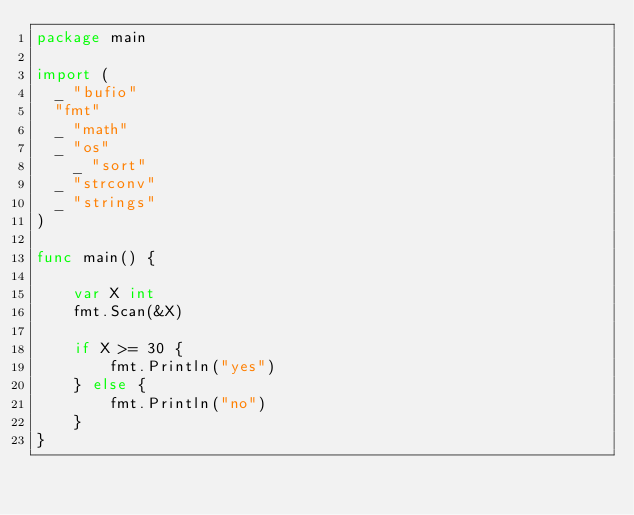Convert code to text. <code><loc_0><loc_0><loc_500><loc_500><_Go_>package main

import (
	_ "bufio"
	"fmt"
	_ "math"
	_ "os"
    _ "sort"
	_ "strconv"
	_ "strings"
)

func main() {
    
    var X int
    fmt.Scan(&X)
    
    if X >= 30 {
        fmt.Println("yes")
    } else {
        fmt.Println("no")
    }
}</code> 